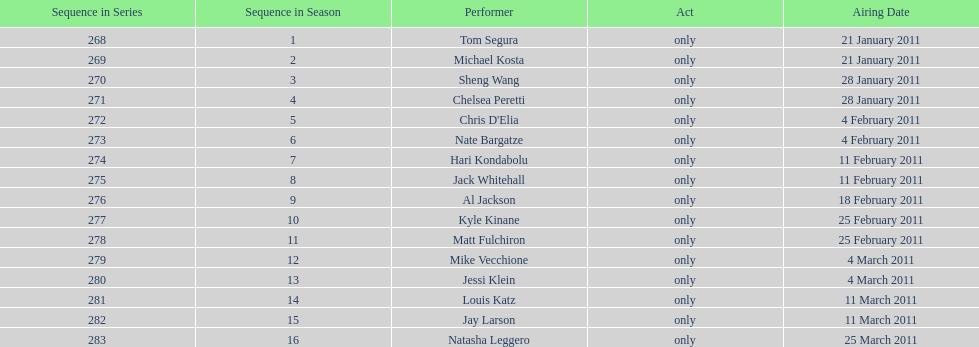How many performers appeared on the air date 21 january 2011? 2. 